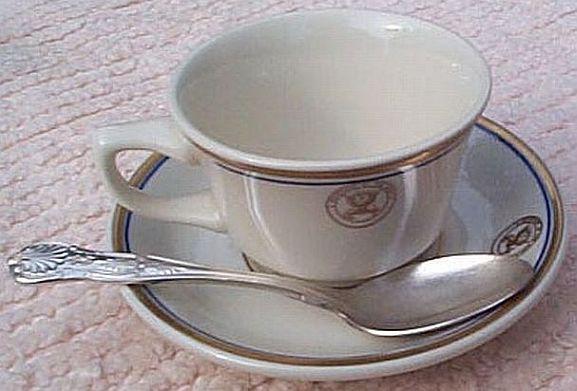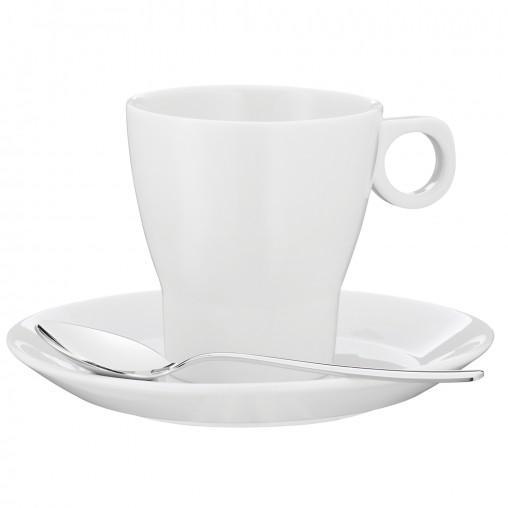The first image is the image on the left, the second image is the image on the right. For the images shown, is this caption "One of the cups has flowers printed on it." true? Answer yes or no. No. 